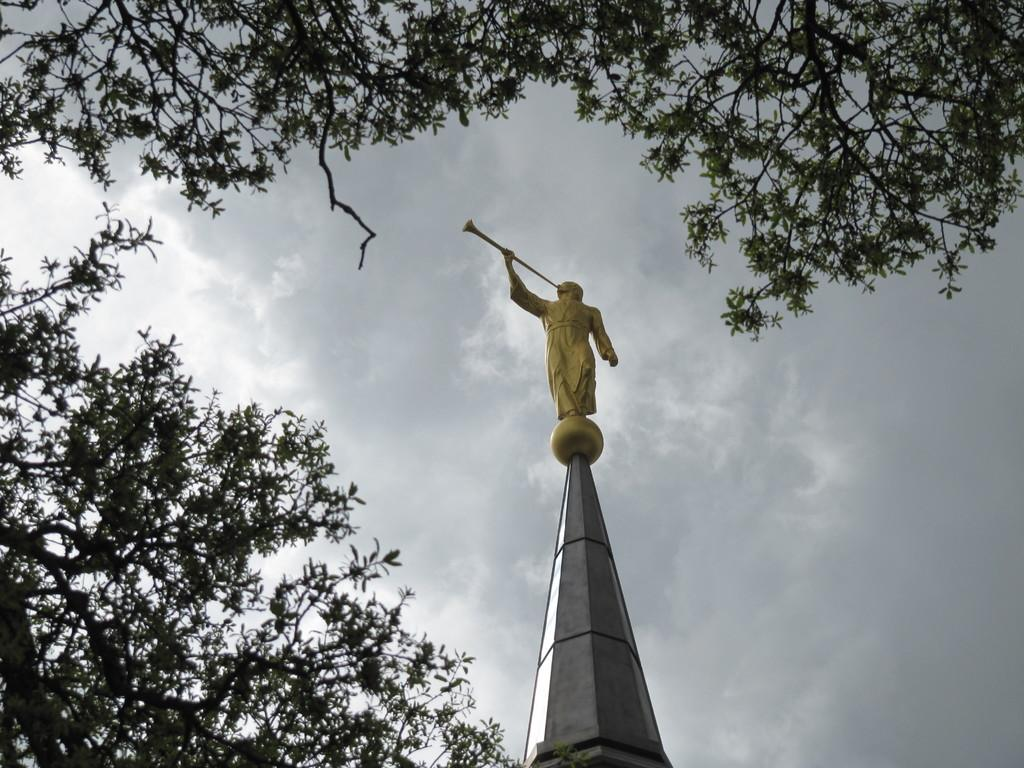What type of vegetation is on the left side of the image? There are trees on the left side of the image. Can you describe the trees at the top of the image? There are trees at the top of the image. What is the main subject in the middle of the image? There is a statue in the middle of the image. What is visible in the background of the image? The sky is visible in the background of the image. What type of degree does the cat have in the image? There is no cat present in the image, so it is not possible to determine what degree it might have. 